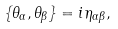Convert formula to latex. <formula><loc_0><loc_0><loc_500><loc_500>\{ \theta _ { \alpha } , \theta _ { \beta } \} = i \eta _ { \alpha \beta } ,</formula> 